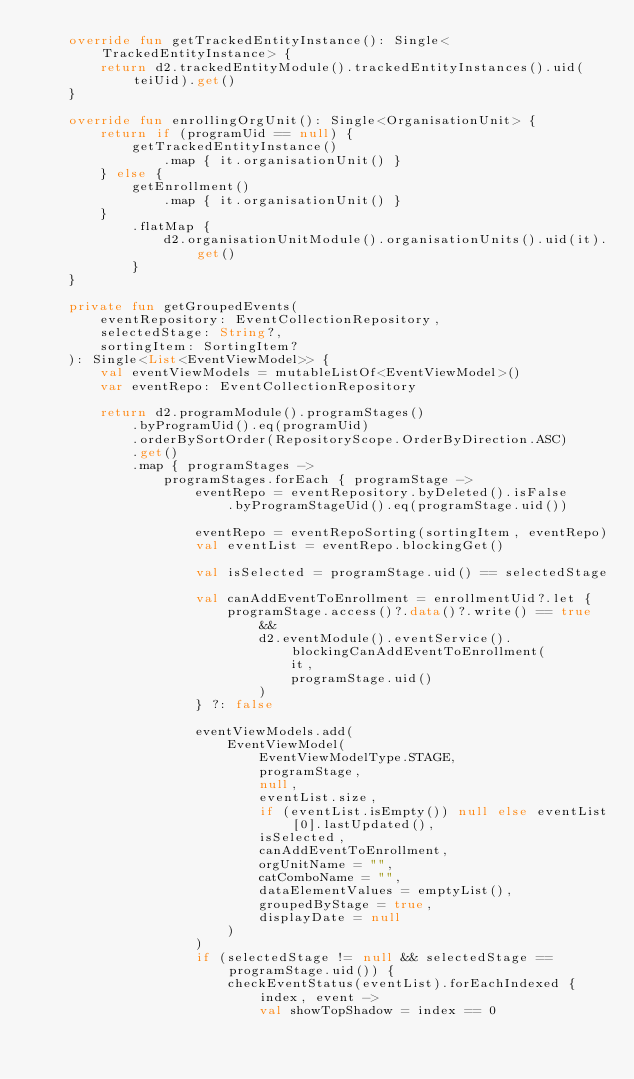Convert code to text. <code><loc_0><loc_0><loc_500><loc_500><_Kotlin_>    override fun getTrackedEntityInstance(): Single<TrackedEntityInstance> {
        return d2.trackedEntityModule().trackedEntityInstances().uid(teiUid).get()
    }

    override fun enrollingOrgUnit(): Single<OrganisationUnit> {
        return if (programUid == null) {
            getTrackedEntityInstance()
                .map { it.organisationUnit() }
        } else {
            getEnrollment()
                .map { it.organisationUnit() }
        }
            .flatMap {
                d2.organisationUnitModule().organisationUnits().uid(it).get()
            }
    }

    private fun getGroupedEvents(
        eventRepository: EventCollectionRepository,
        selectedStage: String?,
        sortingItem: SortingItem?
    ): Single<List<EventViewModel>> {
        val eventViewModels = mutableListOf<EventViewModel>()
        var eventRepo: EventCollectionRepository

        return d2.programModule().programStages()
            .byProgramUid().eq(programUid)
            .orderBySortOrder(RepositoryScope.OrderByDirection.ASC)
            .get()
            .map { programStages ->
                programStages.forEach { programStage ->
                    eventRepo = eventRepository.byDeleted().isFalse
                        .byProgramStageUid().eq(programStage.uid())

                    eventRepo = eventRepoSorting(sortingItem, eventRepo)
                    val eventList = eventRepo.blockingGet()

                    val isSelected = programStage.uid() == selectedStage

                    val canAddEventToEnrollment = enrollmentUid?.let {
                        programStage.access()?.data()?.write() == true &&
                            d2.eventModule().eventService().blockingCanAddEventToEnrollment(
                                it,
                                programStage.uid()
                            )
                    } ?: false

                    eventViewModels.add(
                        EventViewModel(
                            EventViewModelType.STAGE,
                            programStage,
                            null,
                            eventList.size,
                            if (eventList.isEmpty()) null else eventList[0].lastUpdated(),
                            isSelected,
                            canAddEventToEnrollment,
                            orgUnitName = "",
                            catComboName = "",
                            dataElementValues = emptyList(),
                            groupedByStage = true,
                            displayDate = null
                        )
                    )
                    if (selectedStage != null && selectedStage == programStage.uid()) {
                        checkEventStatus(eventList).forEachIndexed { index, event ->
                            val showTopShadow = index == 0</code> 